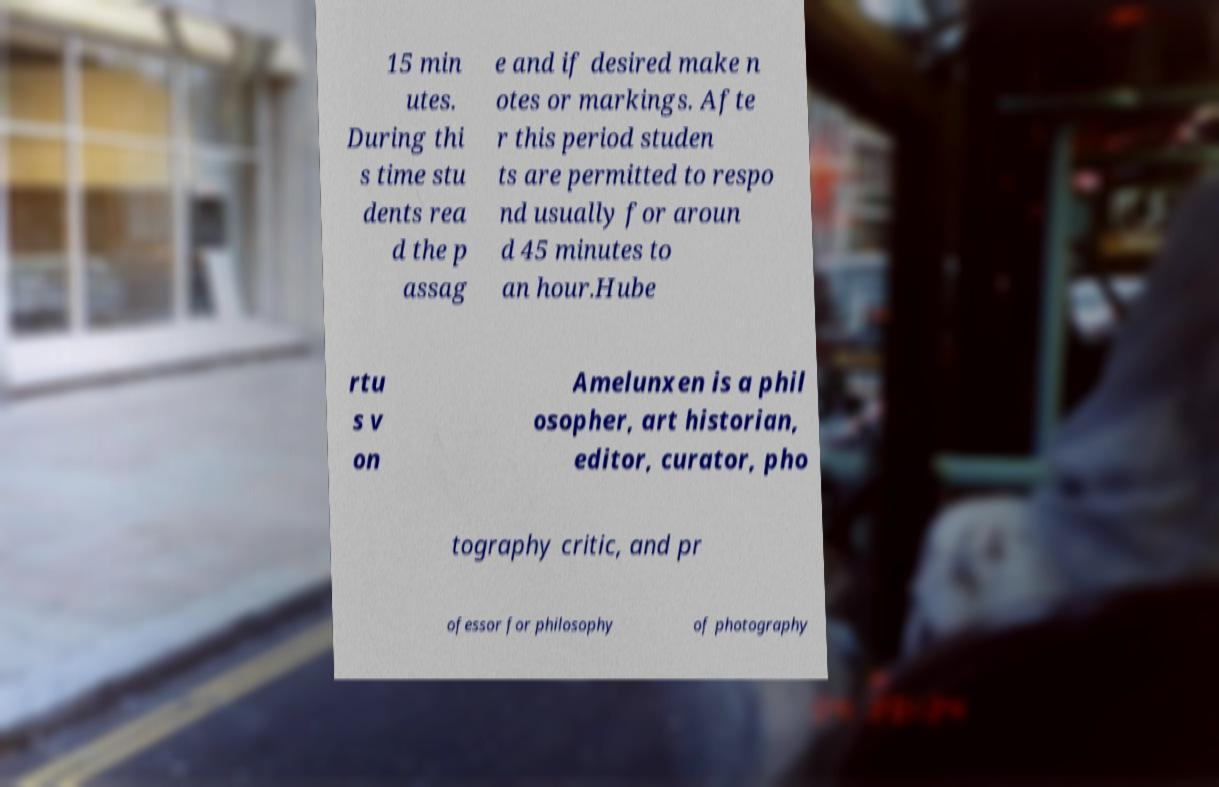Please identify and transcribe the text found in this image. 15 min utes. During thi s time stu dents rea d the p assag e and if desired make n otes or markings. Afte r this period studen ts are permitted to respo nd usually for aroun d 45 minutes to an hour.Hube rtu s v on Amelunxen is a phil osopher, art historian, editor, curator, pho tography critic, and pr ofessor for philosophy of photography 